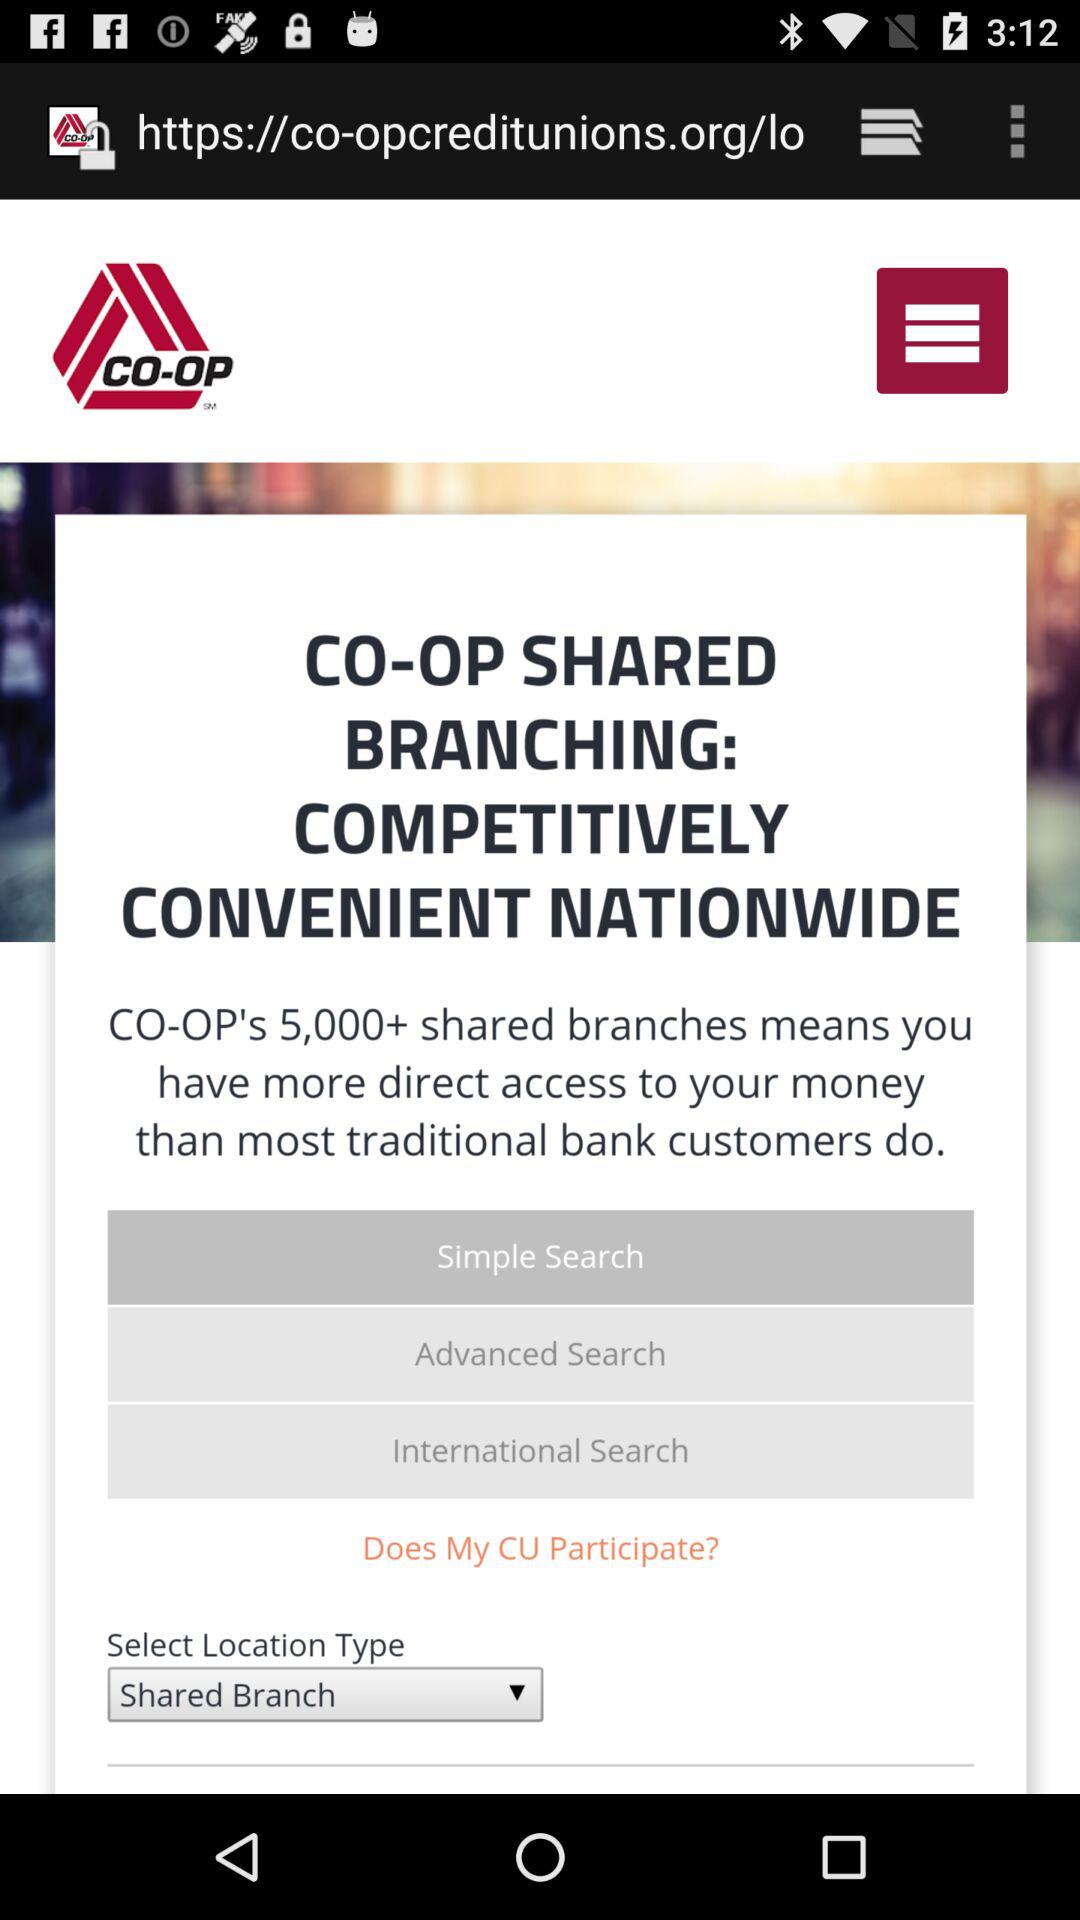How many shared branches are there? There are 5,000+ shared branches. 